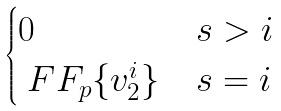<formula> <loc_0><loc_0><loc_500><loc_500>\begin{cases} 0 & s > i \\ \ F F _ { p } \{ v _ { 2 } ^ { i } \} & s = i \end{cases}</formula> 